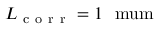<formula> <loc_0><loc_0><loc_500><loc_500>L _ { c o r r } = 1 \ m u m</formula> 